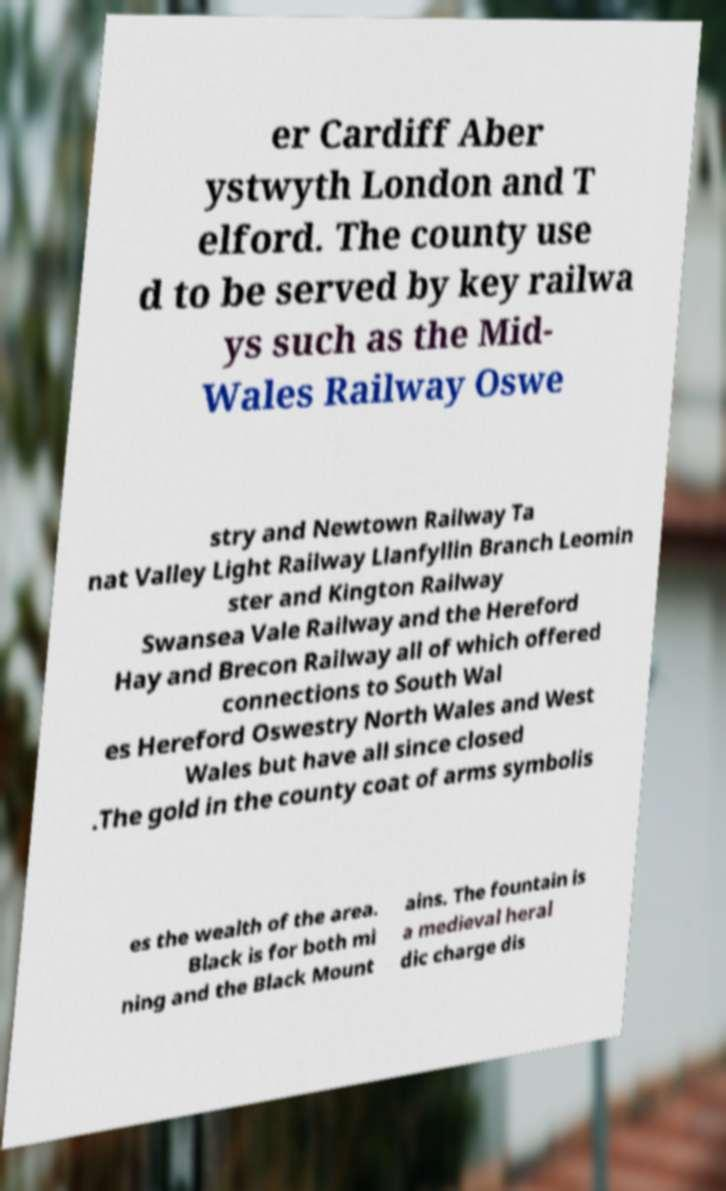Could you assist in decoding the text presented in this image and type it out clearly? er Cardiff Aber ystwyth London and T elford. The county use d to be served by key railwa ys such as the Mid- Wales Railway Oswe stry and Newtown Railway Ta nat Valley Light Railway Llanfyllin Branch Leomin ster and Kington Railway Swansea Vale Railway and the Hereford Hay and Brecon Railway all of which offered connections to South Wal es Hereford Oswestry North Wales and West Wales but have all since closed .The gold in the county coat of arms symbolis es the wealth of the area. Black is for both mi ning and the Black Mount ains. The fountain is a medieval heral dic charge dis 